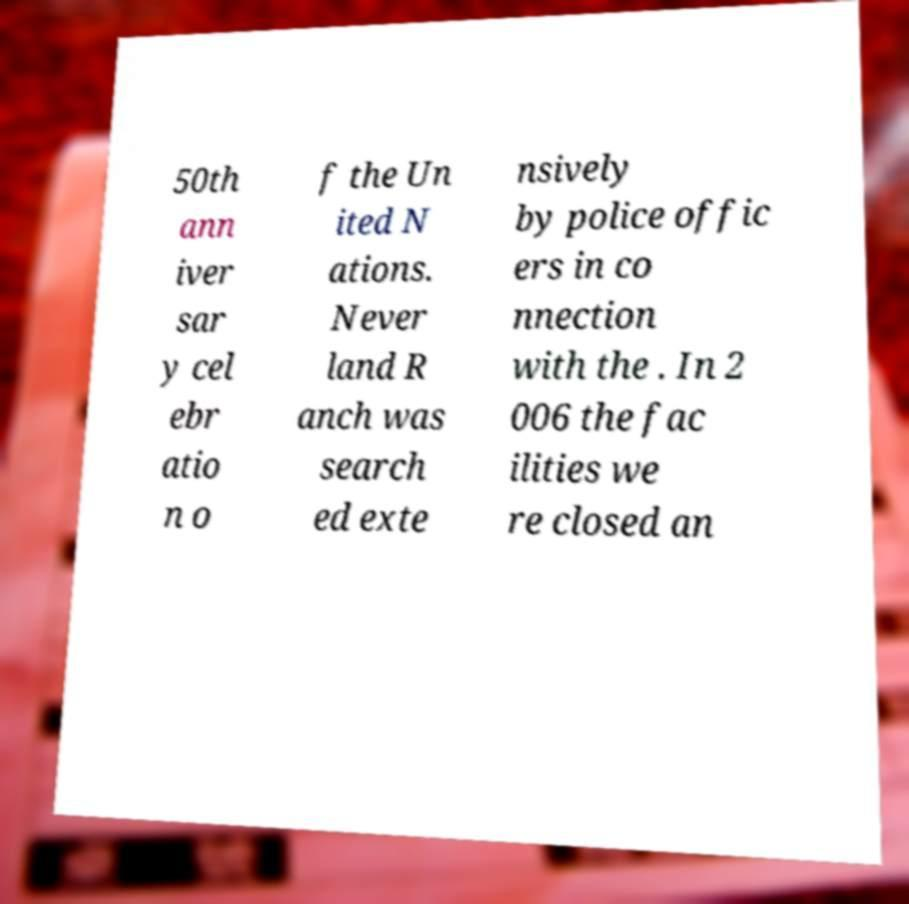Can you accurately transcribe the text from the provided image for me? 50th ann iver sar y cel ebr atio n o f the Un ited N ations. Never land R anch was search ed exte nsively by police offic ers in co nnection with the . In 2 006 the fac ilities we re closed an 